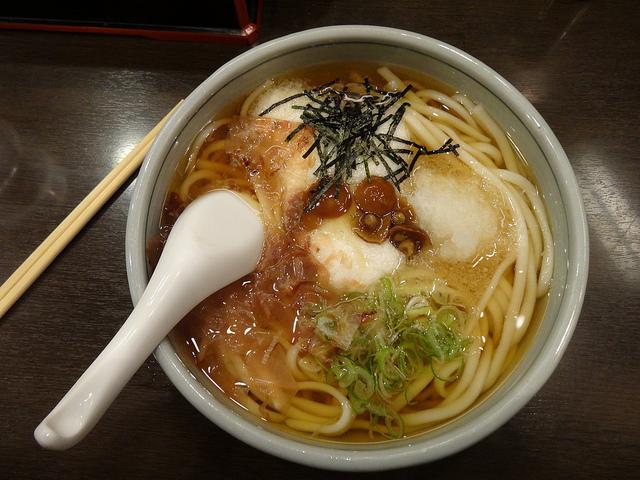What color is the spoon?
Write a very short answer. White. Are those dumplings?
Keep it brief. No. What kind of food is shown?
Give a very brief answer. Soup. 